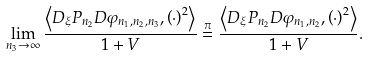Convert formula to latex. <formula><loc_0><loc_0><loc_500><loc_500>\lim _ { n _ { 3 } \to \infty } \frac { \left \langle D _ { \xi } P _ { n _ { 2 } } D \varphi _ { n _ { 1 } , n _ { 2 } , n _ { 3 } } , \left ( \cdot \right ) ^ { 2 } \right \rangle } { 1 + V } \stackrel { \pi } { = } \frac { \left \langle D _ { \xi } P _ { n _ { 2 } } D \varphi _ { n _ { 1 } , n _ { 2 } } , \left ( \cdot \right ) ^ { 2 } \right \rangle } { 1 + V } .</formula> 